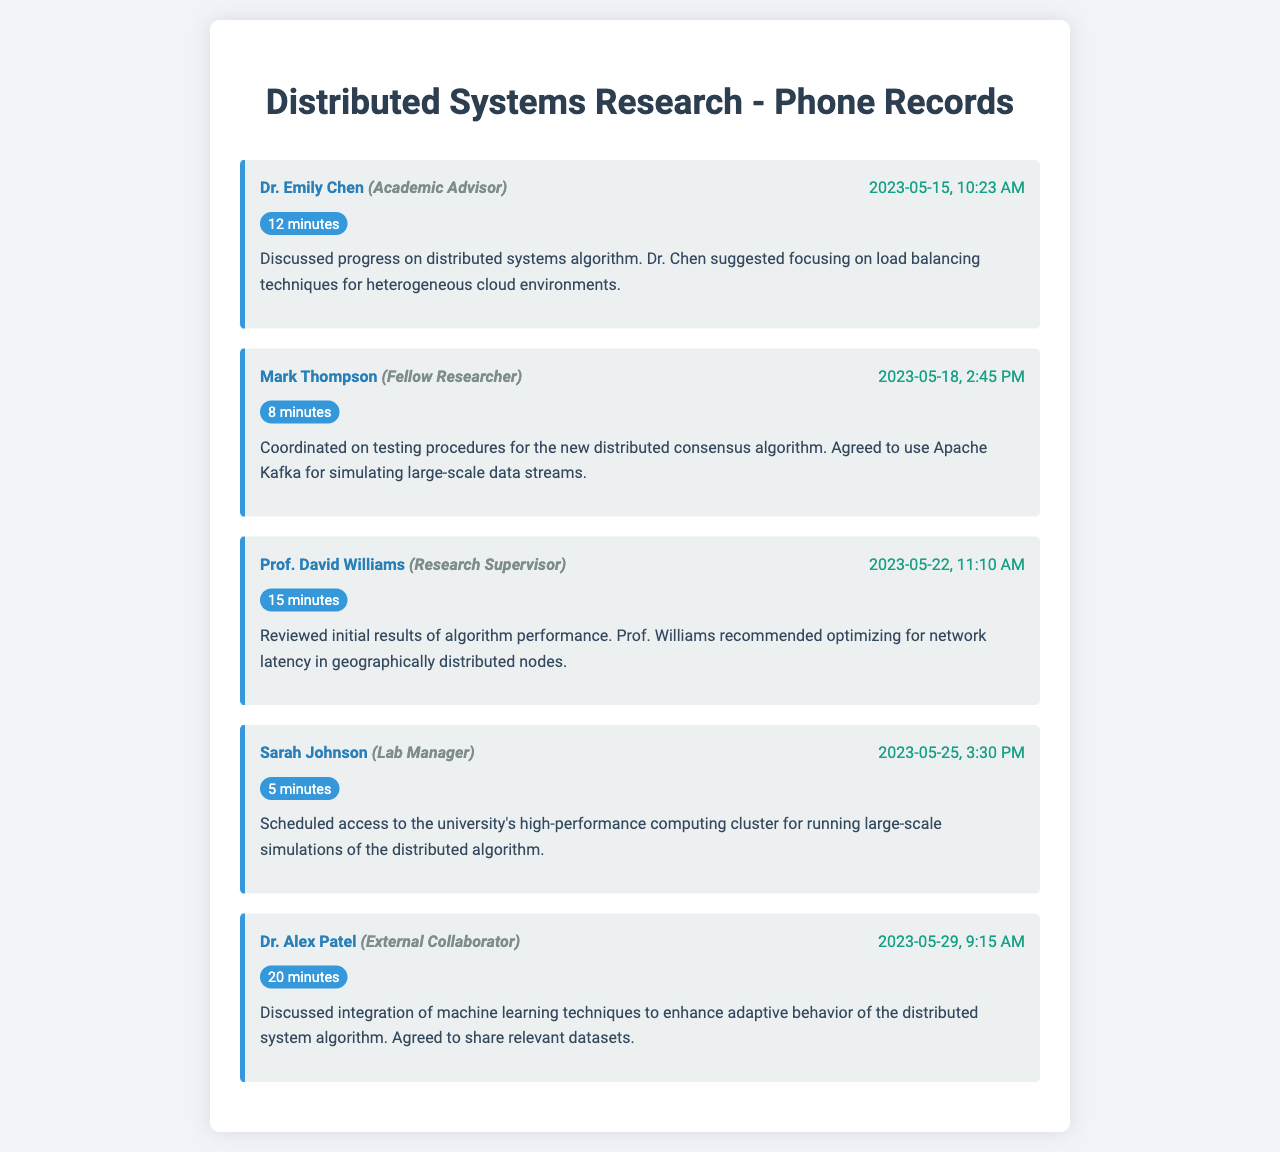What date did the conversation with Dr. Emily Chen occur? The conversation occurred on May 15, 2023, at 10:23 AM.
Answer: May 15, 2023 Who suggested focusing on load balancing techniques? The suggestion was made by Dr. Emily Chen during the conversation about distributed systems algorithm.
Answer: Dr. Emily Chen How long was the call with Mark Thompson? The call lasted for 8 minutes, which is indicated next to the record.
Answer: 8 minutes What algorithm was discussed during the conversation with Prof. David Williams? The conversation reviewed the performance of a distributed systems algorithm.
Answer: distributed systems algorithm What tool was agreed upon for simulating large-scale data streams? Apache Kafka was agreed upon for use in testing procedures.
Answer: Apache Kafka Which research supervisor was involved in reviewing initial results? Prof. David Williams is identified as the research supervisor in the conversation summary.
Answer: Prof. David Williams What was scheduled with Sarah Johnson? Access to the university's high-performance computing cluster was scheduled.
Answer: access to the university's high-performance computing cluster How many minutes was the call with Dr. Alex Patel? The duration of the call was 20 minutes as specified in the document.
Answer: 20 minutes What kind of techniques were discussed to enhance the distributed system algorithm? Machine learning techniques were discussed for enhancing adaptive behavior.
Answer: machine learning techniques 